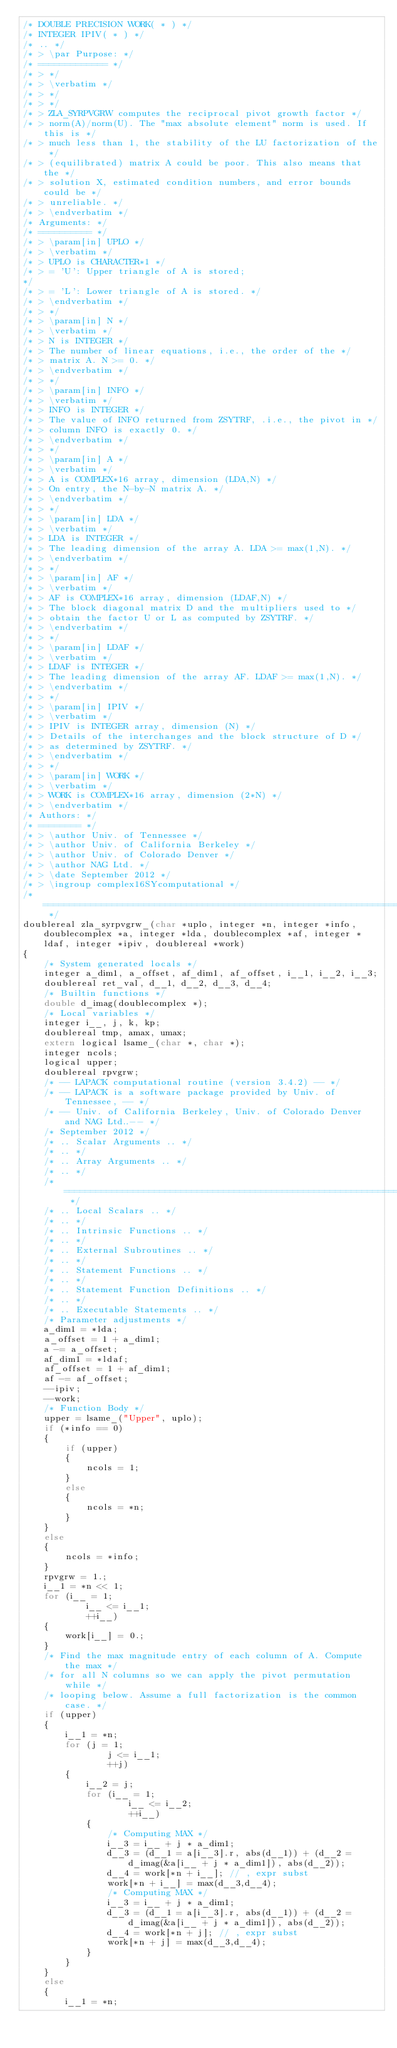<code> <loc_0><loc_0><loc_500><loc_500><_C_>/* DOUBLE PRECISION WORK( * ) */
/* INTEGER IPIV( * ) */
/* .. */
/* > \par Purpose: */
/* ============= */
/* > */
/* > \verbatim */
/* > */
/* > */
/* > ZLA_SYRPVGRW computes the reciprocal pivot growth factor */
/* > norm(A)/norm(U). The "max absolute element" norm is used. If this is */
/* > much less than 1, the stability of the LU factorization of the */
/* > (equilibrated) matrix A could be poor. This also means that the */
/* > solution X, estimated condition numbers, and error bounds could be */
/* > unreliable. */
/* > \endverbatim */
/* Arguments: */
/* ========== */
/* > \param[in] UPLO */
/* > \verbatim */
/* > UPLO is CHARACTER*1 */
/* > = 'U': Upper triangle of A is stored;
*/
/* > = 'L': Lower triangle of A is stored. */
/* > \endverbatim */
/* > */
/* > \param[in] N */
/* > \verbatim */
/* > N is INTEGER */
/* > The number of linear equations, i.e., the order of the */
/* > matrix A. N >= 0. */
/* > \endverbatim */
/* > */
/* > \param[in] INFO */
/* > \verbatim */
/* > INFO is INTEGER */
/* > The value of INFO returned from ZSYTRF, .i.e., the pivot in */
/* > column INFO is exactly 0. */
/* > \endverbatim */
/* > */
/* > \param[in] A */
/* > \verbatim */
/* > A is COMPLEX*16 array, dimension (LDA,N) */
/* > On entry, the N-by-N matrix A. */
/* > \endverbatim */
/* > */
/* > \param[in] LDA */
/* > \verbatim */
/* > LDA is INTEGER */
/* > The leading dimension of the array A. LDA >= max(1,N). */
/* > \endverbatim */
/* > */
/* > \param[in] AF */
/* > \verbatim */
/* > AF is COMPLEX*16 array, dimension (LDAF,N) */
/* > The block diagonal matrix D and the multipliers used to */
/* > obtain the factor U or L as computed by ZSYTRF. */
/* > \endverbatim */
/* > */
/* > \param[in] LDAF */
/* > \verbatim */
/* > LDAF is INTEGER */
/* > The leading dimension of the array AF. LDAF >= max(1,N). */
/* > \endverbatim */
/* > */
/* > \param[in] IPIV */
/* > \verbatim */
/* > IPIV is INTEGER array, dimension (N) */
/* > Details of the interchanges and the block structure of D */
/* > as determined by ZSYTRF. */
/* > \endverbatim */
/* > */
/* > \param[in] WORK */
/* > \verbatim */
/* > WORK is COMPLEX*16 array, dimension (2*N) */
/* > \endverbatim */
/* Authors: */
/* ======== */
/* > \author Univ. of Tennessee */
/* > \author Univ. of California Berkeley */
/* > \author Univ. of Colorado Denver */
/* > \author NAG Ltd. */
/* > \date September 2012 */
/* > \ingroup complex16SYcomputational */
/* ===================================================================== */
doublereal zla_syrpvgrw_(char *uplo, integer *n, integer *info, doublecomplex *a, integer *lda, doublecomplex *af, integer *ldaf, integer *ipiv, doublereal *work)
{
    /* System generated locals */
    integer a_dim1, a_offset, af_dim1, af_offset, i__1, i__2, i__3;
    doublereal ret_val, d__1, d__2, d__3, d__4;
    /* Builtin functions */
    double d_imag(doublecomplex *);
    /* Local variables */
    integer i__, j, k, kp;
    doublereal tmp, amax, umax;
    extern logical lsame_(char *, char *);
    integer ncols;
    logical upper;
    doublereal rpvgrw;
    /* -- LAPACK computational routine (version 3.4.2) -- */
    /* -- LAPACK is a software package provided by Univ. of Tennessee, -- */
    /* -- Univ. of California Berkeley, Univ. of Colorado Denver and NAG Ltd..-- */
    /* September 2012 */
    /* .. Scalar Arguments .. */
    /* .. */
    /* .. Array Arguments .. */
    /* .. */
    /* ===================================================================== */
    /* .. Local Scalars .. */
    /* .. */
    /* .. Intrinsic Functions .. */
    /* .. */
    /* .. External Subroutines .. */
    /* .. */
    /* .. Statement Functions .. */
    /* .. */
    /* .. Statement Function Definitions .. */
    /* .. */
    /* .. Executable Statements .. */
    /* Parameter adjustments */
    a_dim1 = *lda;
    a_offset = 1 + a_dim1;
    a -= a_offset;
    af_dim1 = *ldaf;
    af_offset = 1 + af_dim1;
    af -= af_offset;
    --ipiv;
    --work;
    /* Function Body */
    upper = lsame_("Upper", uplo);
    if (*info == 0)
    {
        if (upper)
        {
            ncols = 1;
        }
        else
        {
            ncols = *n;
        }
    }
    else
    {
        ncols = *info;
    }
    rpvgrw = 1.;
    i__1 = *n << 1;
    for (i__ = 1;
            i__ <= i__1;
            ++i__)
    {
        work[i__] = 0.;
    }
    /* Find the max magnitude entry of each column of A. Compute the max */
    /* for all N columns so we can apply the pivot permutation while */
    /* looping below. Assume a full factorization is the common case. */
    if (upper)
    {
        i__1 = *n;
        for (j = 1;
                j <= i__1;
                ++j)
        {
            i__2 = j;
            for (i__ = 1;
                    i__ <= i__2;
                    ++i__)
            {
                /* Computing MAX */
                i__3 = i__ + j * a_dim1;
                d__3 = (d__1 = a[i__3].r, abs(d__1)) + (d__2 = d_imag(&a[i__ + j * a_dim1]), abs(d__2));
                d__4 = work[*n + i__]; // , expr subst
                work[*n + i__] = max(d__3,d__4);
                /* Computing MAX */
                i__3 = i__ + j * a_dim1;
                d__3 = (d__1 = a[i__3].r, abs(d__1)) + (d__2 = d_imag(&a[i__ + j * a_dim1]), abs(d__2));
                d__4 = work[*n + j]; // , expr subst
                work[*n + j] = max(d__3,d__4);
            }
        }
    }
    else
    {
        i__1 = *n;</code> 